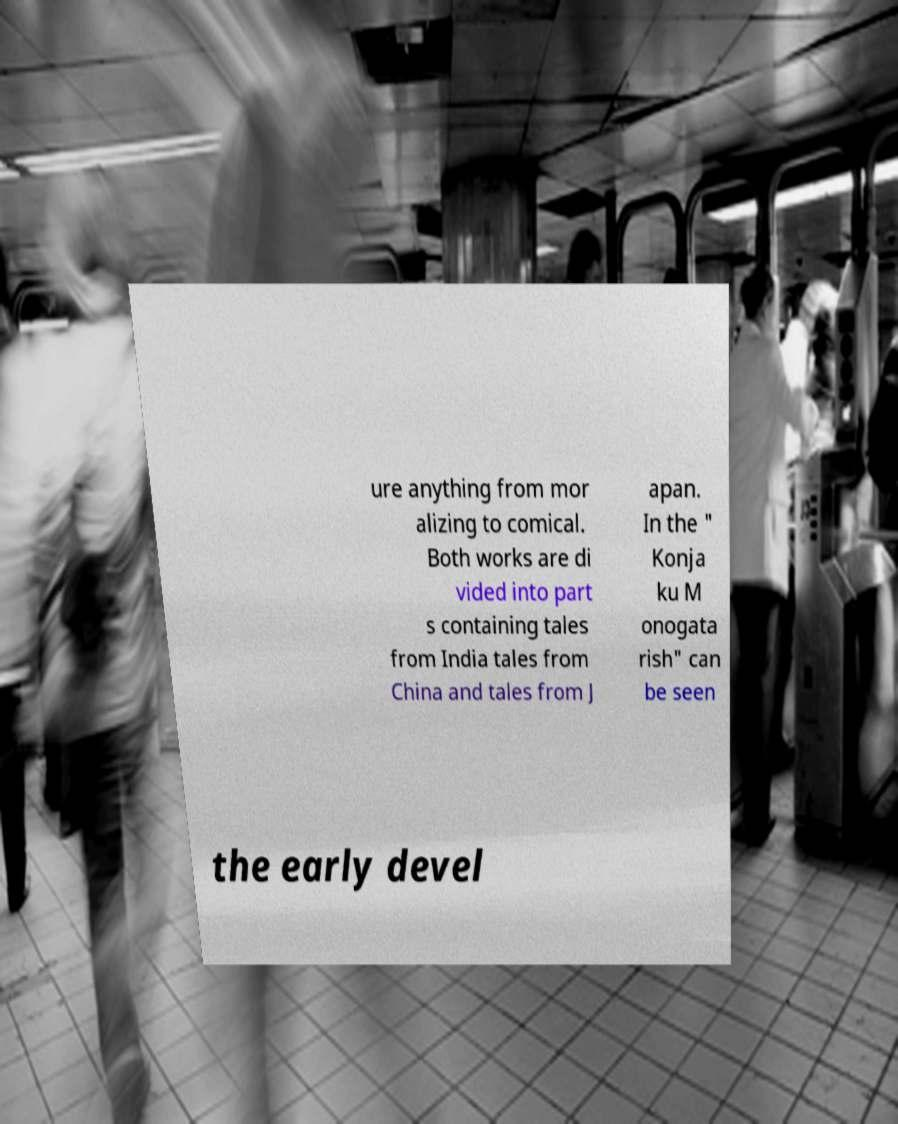Could you assist in decoding the text presented in this image and type it out clearly? ure anything from mor alizing to comical. Both works are di vided into part s containing tales from India tales from China and tales from J apan. In the " Konja ku M onogata rish" can be seen the early devel 